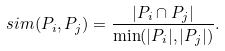<formula> <loc_0><loc_0><loc_500><loc_500>s i m ( P _ { i } , P _ { j } ) = \frac { | P _ { i } \cap P _ { j } | } { \min ( | P _ { i } | , | P _ { j } | ) } .</formula> 